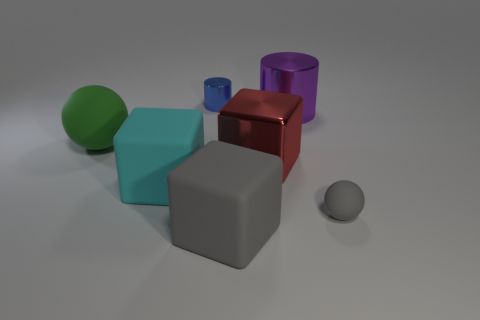Add 1 big matte objects. How many objects exist? 8 Subtract all cylinders. How many objects are left? 5 Add 7 large metallic blocks. How many large metallic blocks exist? 8 Subtract 0 green cylinders. How many objects are left? 7 Subtract all small yellow metallic blocks. Subtract all purple objects. How many objects are left? 6 Add 5 gray matte spheres. How many gray matte spheres are left? 6 